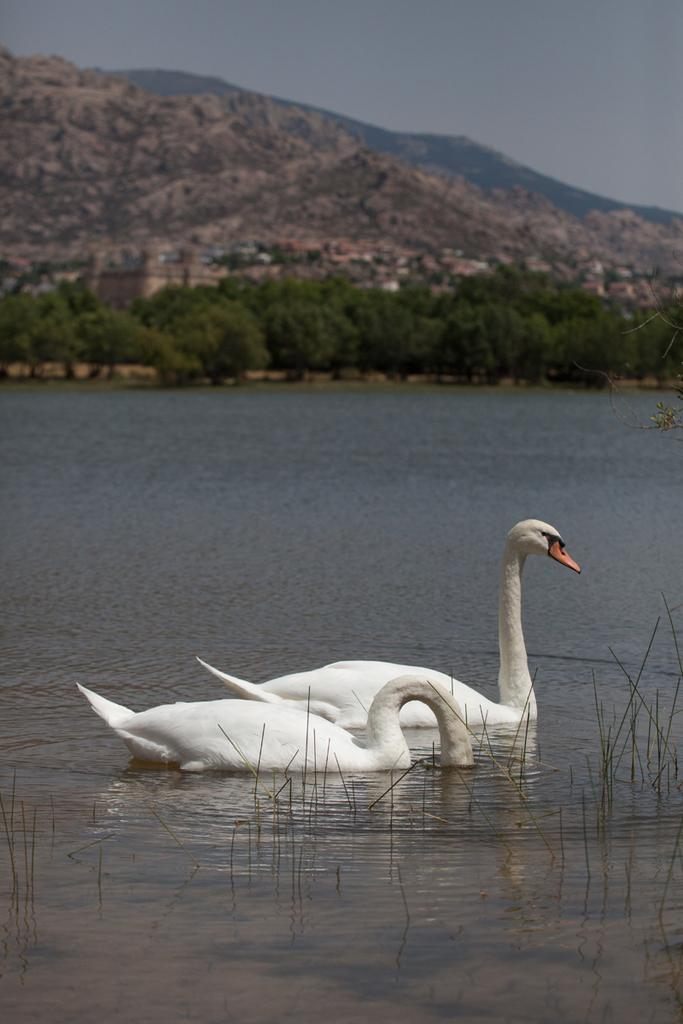What animals can be seen in the water in the image? There are swans in the water in the image. What type of vegetation is visible in the image? There are trees visible in the image. What geographical feature is present in the image? There is a hill in the image. What can be seen in the sky in the image? Clouds are present in the sky in the image. What type of range is visible in the image? There is no range present in the image; it features swans in the water, trees, a hill, and clouds in the sky. Can you tell me how many representatives are depicted in the image? There are no representatives present in the image. 